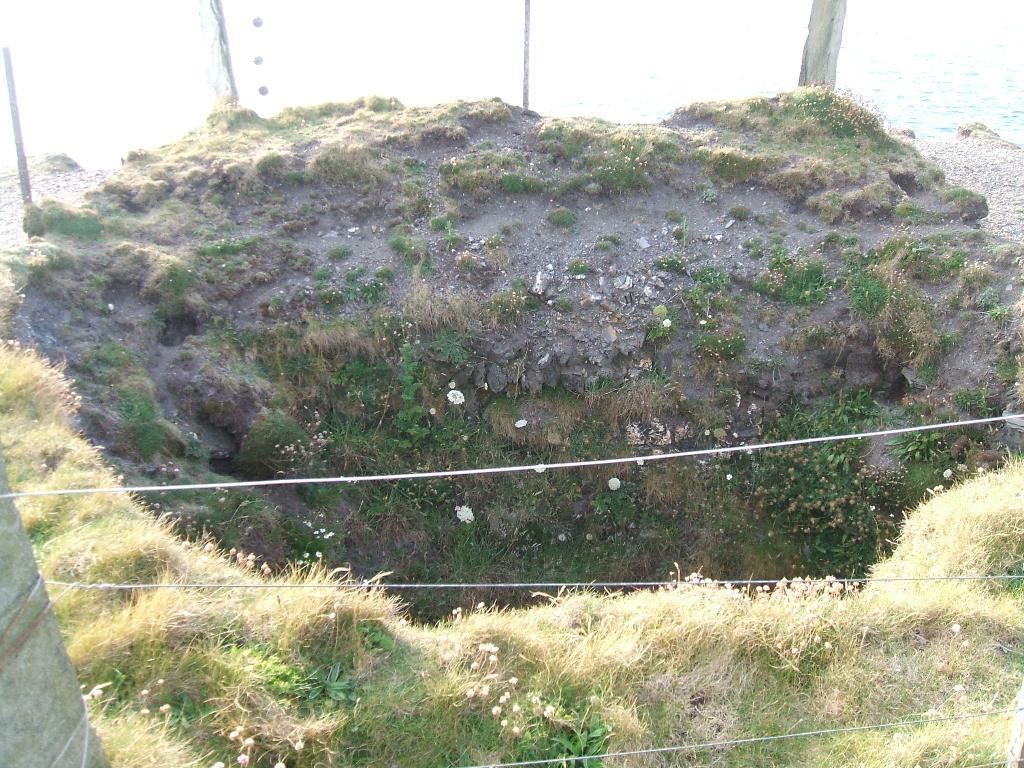How would you summarize this image in a sentence or two? In the image we can see there is a ground which is covered with grass and low vegetation. Behind there is water. 